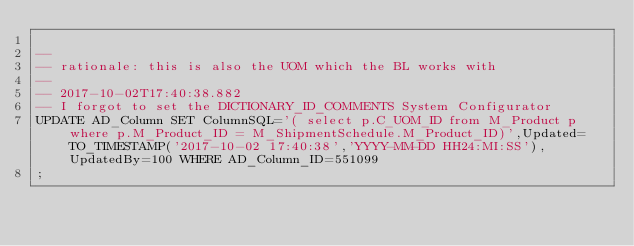Convert code to text. <code><loc_0><loc_0><loc_500><loc_500><_SQL_>
--
-- rationale: this is also the UOM which the BL works with
--
-- 2017-10-02T17:40:38.882
-- I forgot to set the DICTIONARY_ID_COMMENTS System Configurator
UPDATE AD_Column SET ColumnSQL='( select p.C_UOM_ID from M_Product p where p.M_Product_ID = M_ShipmentSchedule.M_Product_ID)',Updated=TO_TIMESTAMP('2017-10-02 17:40:38','YYYY-MM-DD HH24:MI:SS'),UpdatedBy=100 WHERE AD_Column_ID=551099
;
</code> 